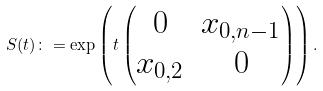Convert formula to latex. <formula><loc_0><loc_0><loc_500><loc_500>S ( t ) \colon = \exp \left ( t \begin{pmatrix} 0 & x _ { 0 , n - 1 } \\ x _ { 0 , 2 } & 0 \end{pmatrix} \right ) .</formula> 